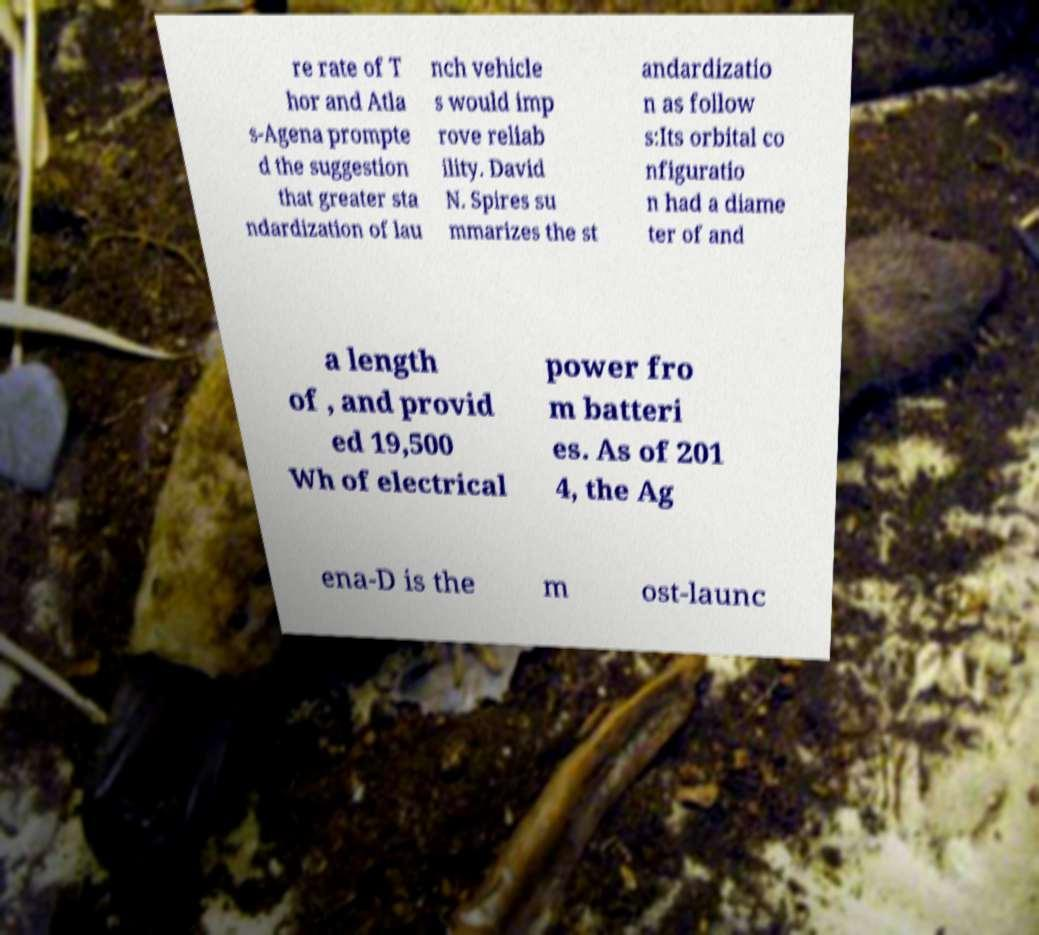I need the written content from this picture converted into text. Can you do that? re rate of T hor and Atla s-Agena prompte d the suggestion that greater sta ndardization of lau nch vehicle s would imp rove reliab ility. David N. Spires su mmarizes the st andardizatio n as follow s:Its orbital co nfiguratio n had a diame ter of and a length of , and provid ed 19,500 Wh of electrical power fro m batteri es. As of 201 4, the Ag ena-D is the m ost-launc 